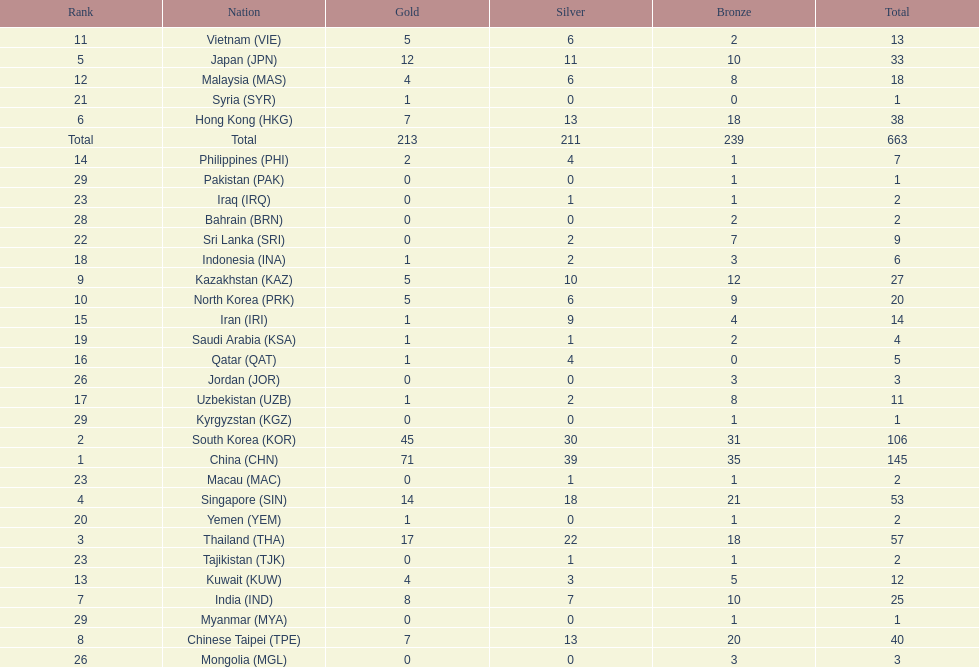How many nations earned at least ten bronze medals? 9. 